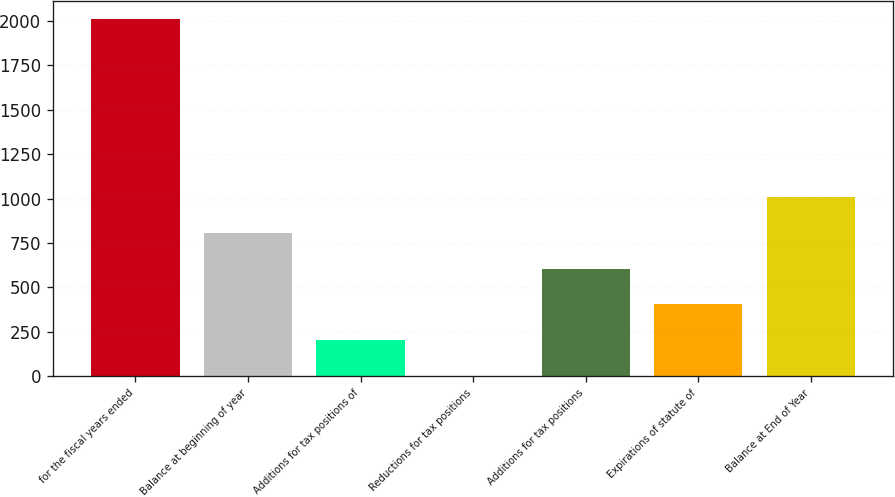Convert chart to OTSL. <chart><loc_0><loc_0><loc_500><loc_500><bar_chart><fcel>for the fiscal years ended<fcel>Balance at beginning of year<fcel>Additions for tax positions of<fcel>Reductions for tax positions<fcel>Additions for tax positions<fcel>Expirations of statute of<fcel>Balance at End of Year<nl><fcel>2014<fcel>807.04<fcel>203.56<fcel>2.4<fcel>605.88<fcel>404.72<fcel>1008.2<nl></chart> 